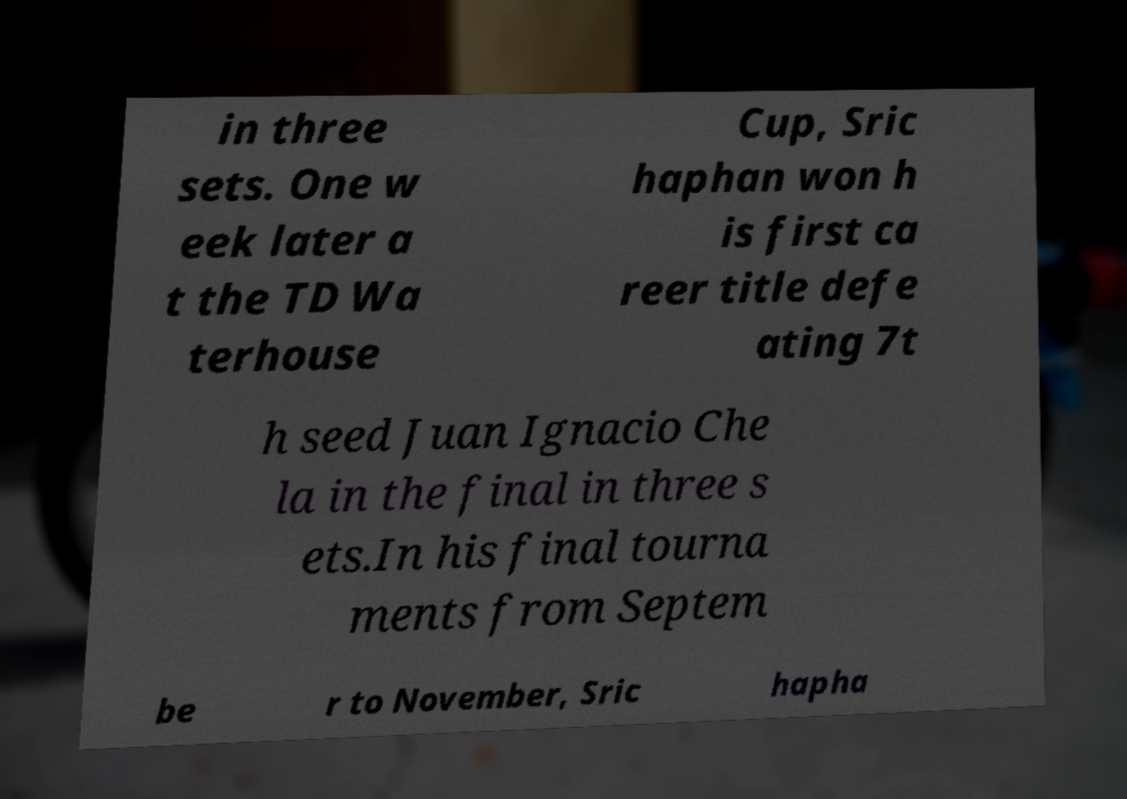I need the written content from this picture converted into text. Can you do that? in three sets. One w eek later a t the TD Wa terhouse Cup, Sric haphan won h is first ca reer title defe ating 7t h seed Juan Ignacio Che la in the final in three s ets.In his final tourna ments from Septem be r to November, Sric hapha 